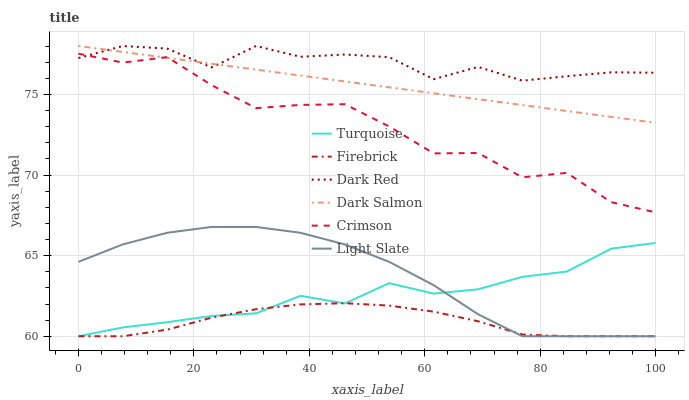Does Firebrick have the minimum area under the curve?
Answer yes or no. Yes. Does Dark Red have the maximum area under the curve?
Answer yes or no. Yes. Does Light Slate have the minimum area under the curve?
Answer yes or no. No. Does Light Slate have the maximum area under the curve?
Answer yes or no. No. Is Dark Salmon the smoothest?
Answer yes or no. Yes. Is Crimson the roughest?
Answer yes or no. Yes. Is Light Slate the smoothest?
Answer yes or no. No. Is Light Slate the roughest?
Answer yes or no. No. Does Dark Red have the lowest value?
Answer yes or no. No. Does Light Slate have the highest value?
Answer yes or no. No. Is Firebrick less than Dark Red?
Answer yes or no. Yes. Is Crimson greater than Turquoise?
Answer yes or no. Yes. Does Firebrick intersect Dark Red?
Answer yes or no. No. 